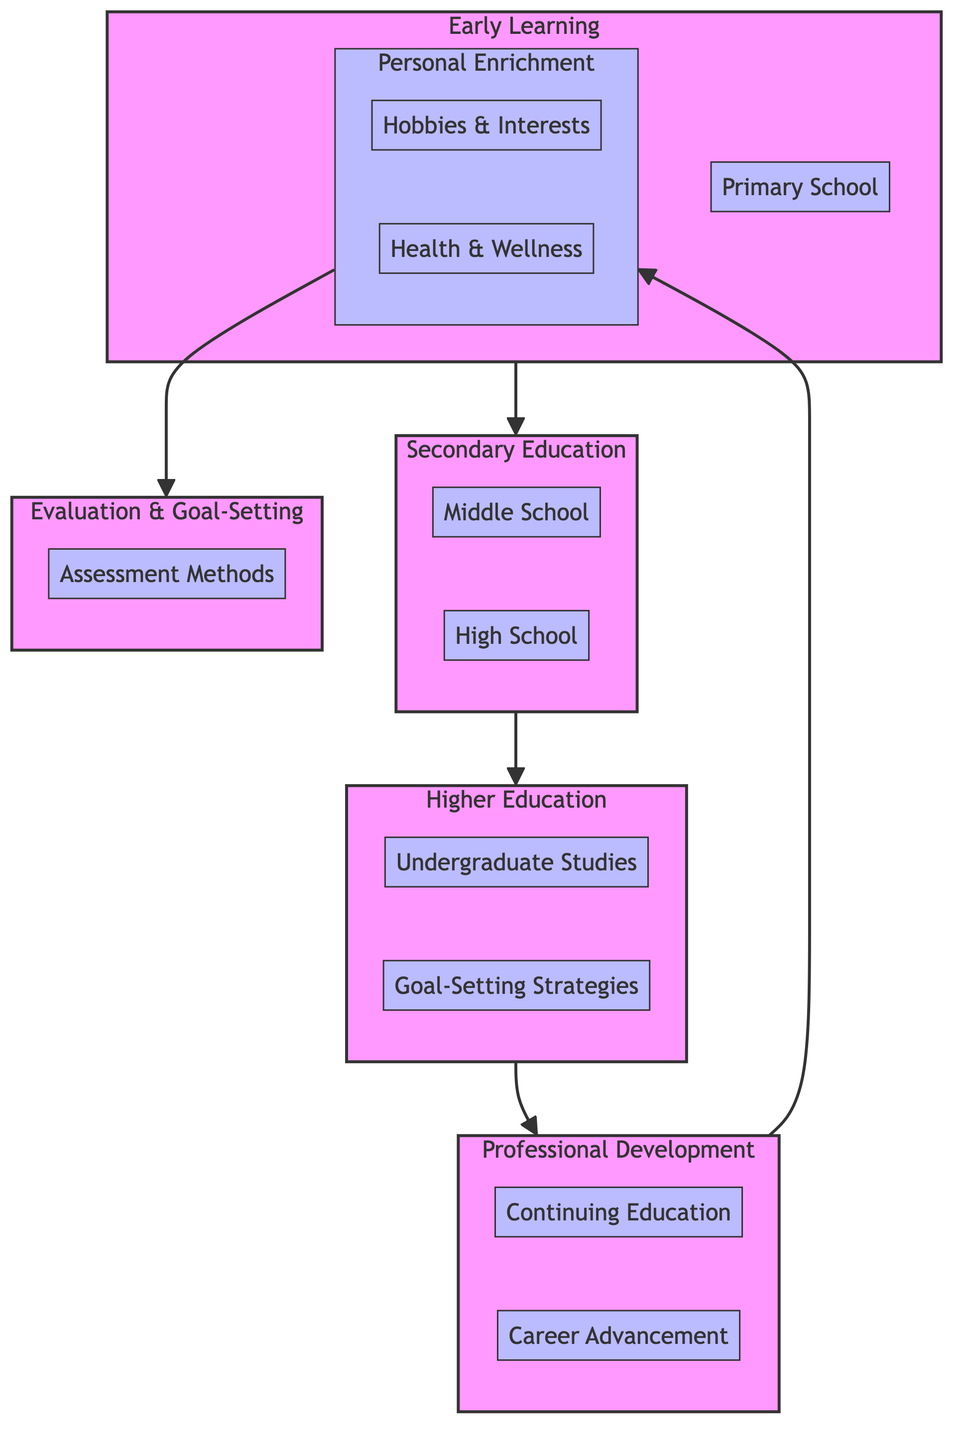What are the two main components of Early Learning in the diagram? The diagram identifies two elements within the Early Learning block: 'Preschool Education' and 'Primary School.' These are the primary components that contribute to early educational stages.
Answer: Preschool Education, Primary School How many stages are there in the lifelong learning curriculum diagram? The diagram includes five distinct stages: Early Learning, Secondary Education, Higher Education, Professional Development, and Personal Enrichment. This totals to five stages within the lifelong learning curriculum.
Answer: Five What skills are associated with Higher Education in the diagram? The Higher Education block contains two elements: 'Undergraduate Studies' and 'Graduate Studies.' The corresponding skills for these elements are 'Specialized Knowledge,' 'Research Skills,' 'Critical Analysis,' 'Expertise Development,' 'Networking,' and 'Project Management.'
Answer: Specialized Knowledge, Research Skills, Critical Analysis, Expertise Development, Networking, Project Management Which evaluation method involves self-reflection? Within the Evaluation & Goal-Setting block, the 'Assessment Methods' element features 'Self-Assessment Tools' as a key resource. 'Self-Reflection' is identified as a skill associated with this method.
Answer: Self-Assessment Tools How are Professional Development and Personal Enrichment connected in the diagram? In the flow of the diagram, Professional Development leads directly to Personal Enrichment, indicating that as individuals progress through professional development, they often gain insights or knowledge that facilitates personal enrichment activities.
Answer: Directly connected Which resource is linked to the 'Hobbies & Interests' element? The 'Hobbies & Interests' element under Personal Enrichment lists several resources, one of which is 'Community Classes.' This indicates an educational approach to exploring personal interests and hobbies.
Answer: Community Classes 